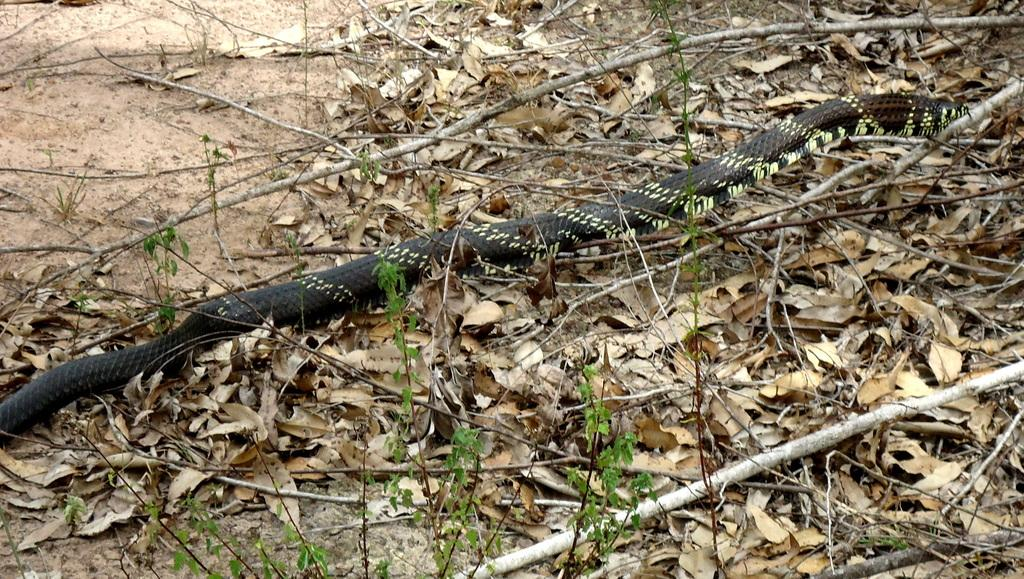What type of animal is in the image? There is a black color snake in the image. What other elements can be seen in the image besides the snake? There are small plants, sticks, and dry leaves on the ground in the image. What type of sugar is sprinkled on the snake in the image? There is no sugar present in the image; it features a black color snake and other natural elements. 